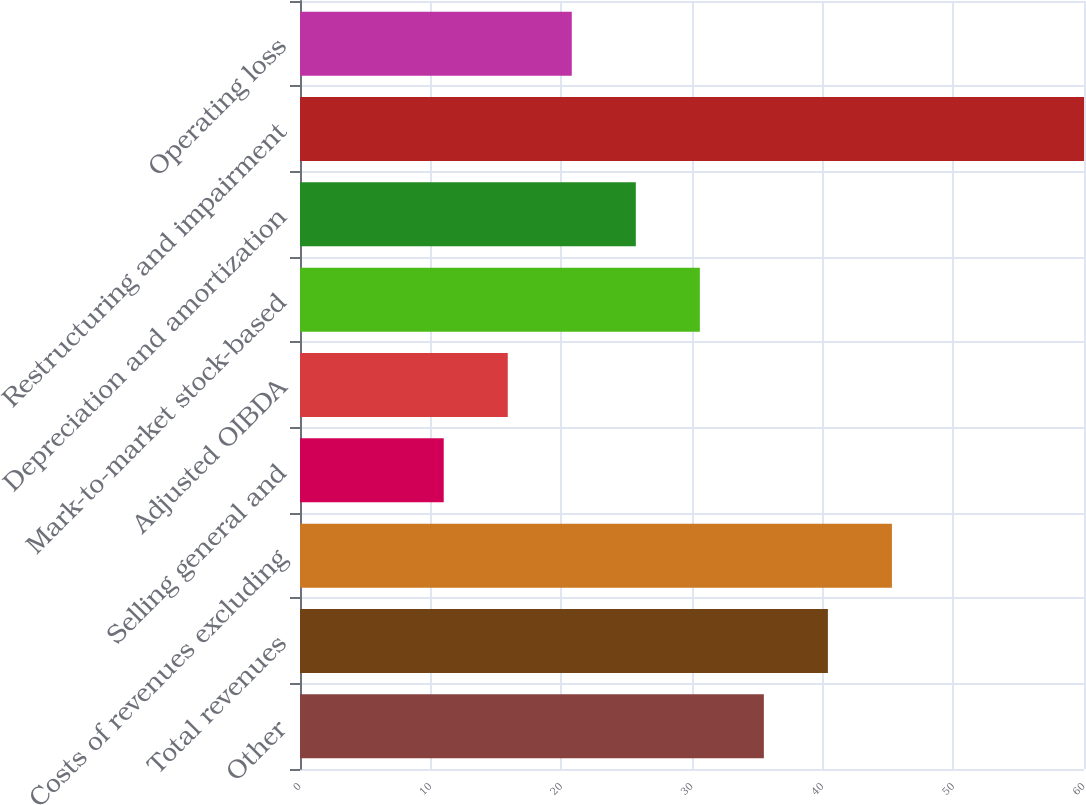Convert chart. <chart><loc_0><loc_0><loc_500><loc_500><bar_chart><fcel>Other<fcel>Total revenues<fcel>Costs of revenues excluding<fcel>Selling general and<fcel>Adjusted OIBDA<fcel>Mark-to-market stock-based<fcel>Depreciation and amortization<fcel>Restructuring and impairment<fcel>Operating loss<nl><fcel>35.5<fcel>40.4<fcel>45.3<fcel>11<fcel>15.9<fcel>30.6<fcel>25.7<fcel>60<fcel>20.8<nl></chart> 